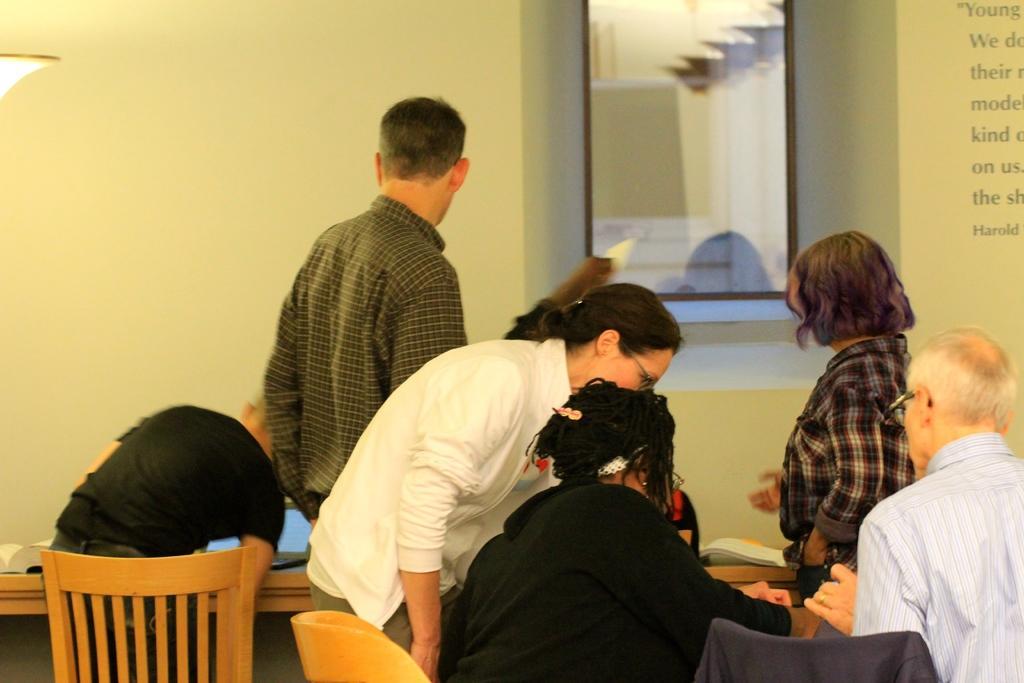Please provide a concise description of this image. In this image, There is a table which is in yellow color, There are some chairs in yellow color, There are some people sitting on the chairs, In the middle there is a man standing, In the background there is a cream color wall and in the right side there is a woman standing and pointing something on the table. 